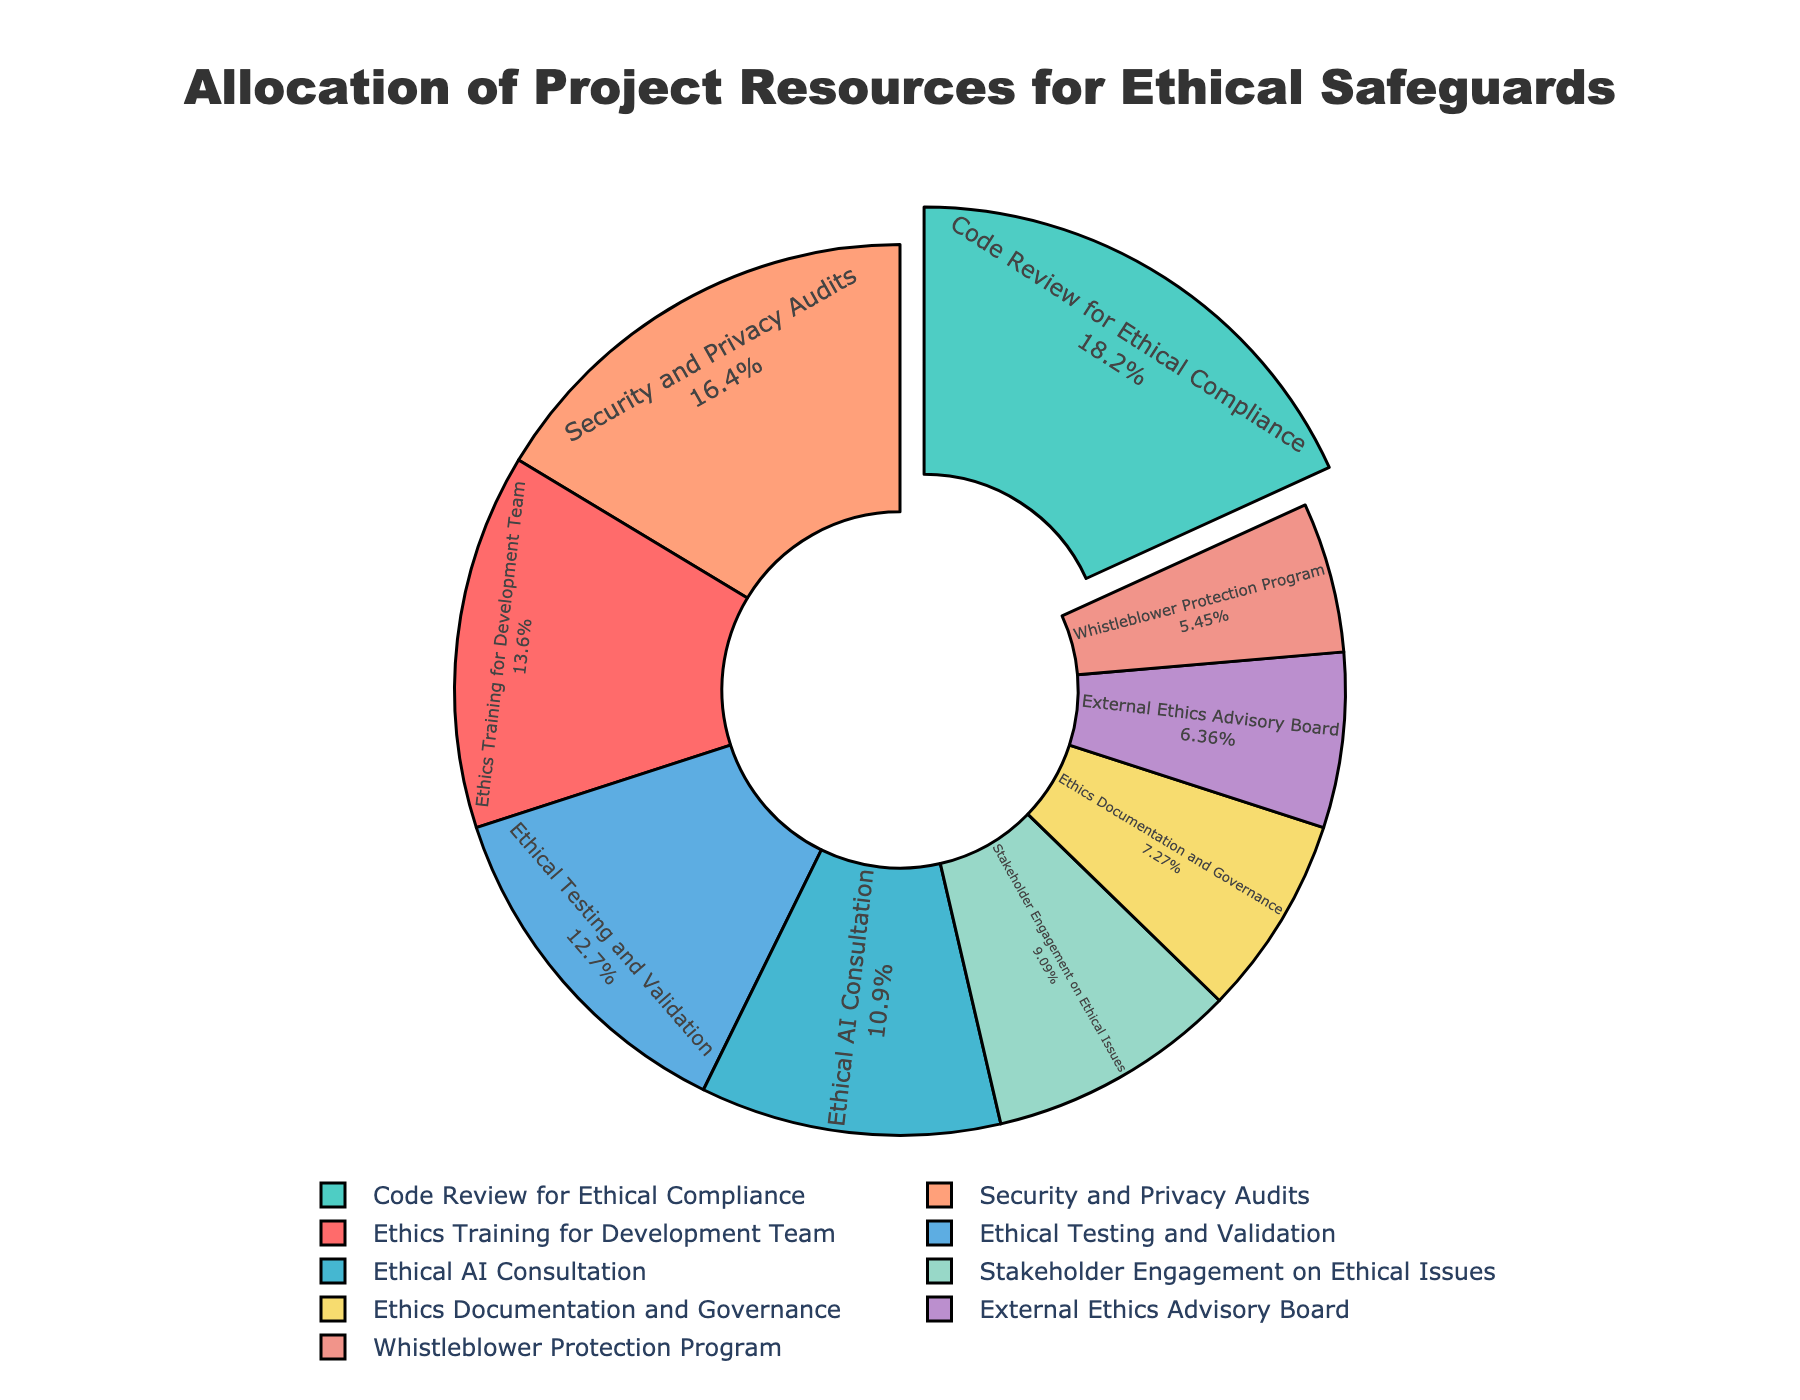What's the largest allocation category? The figure highlights and slightly pulls out the slice with the largest allocation. This visual cue points to "Code Review for Ethical Compliance".
Answer: Code Review for Ethical Compliance What's the combined percentage for Ethics Training for Development Team, Ethical Testing and Validation, and Security and Privacy Audits together? To get the combined percentage, add the percentages of the respective categories: Ethics Training for Development Team (15) + Ethical Testing and Validation (14) + Security and Privacy Audits (18). Calculation: 15 + 14 + 18 = 47.
Answer: 47 Which category has the lowest allocation percentage? By looking at the slices, the smallest slice corresponds to the "Whistleblower Protection Program" category, which has the lowest allocation.
Answer: Whistleblower Protection Program Are there more resources allocated to External Ethics Advisory Board or Stakeholder Engagement on Ethical Issues? Compare the percentages of External Ethics Advisory Board (7) and Stakeholder Engagement on Ethical Issues (10). Since 10% is greater than 7%, Stakeholder Engagement on Ethical Issues has more resources allocated.
Answer: Stakeholder Engagement on Ethical Issues What is the color of the slice representing "Ethics Training for Development Team"? The plot uses specific colors for each category, and the slice labeled "Ethics Training for Development Team" is colored red.
Answer: Red How much more percentage is allocated to Security and Privacy Audits compared to Ethics Documentation and Governance? Subtract the percentage of Ethics Documentation and Governance (8) from Security and Privacy Audits (18). Calculation: 18 - 8 = 10.
Answer: 10 What two categories have the closest allocation percentages? By examining the percentages, Ethical AI Consultation (12) and Ethical Testing and Validation (14) have close allocations with a difference of only 2%.
Answer: Ethical AI Consultation and Ethical Testing and Validation What is the average allocation percentage for all the categories? Sum all the percentages and divide by the number of categories, (15 + 20 + 12 + 18 + 10 + 8 + 7 + 14 + 6) / 9 = 110 / 9 ≈ 12.22.
Answer: ~12.22 Which slice is colored blue, and what percentage does it represent? The plot assigns blue to "Security and Privacy Audits", which is represented by an 18% slice.
Answer: Security and Privacy Audits, 18% How many categories have more than 10% allocation? Identify the categories with percentages over 10: Ethics Training for Development Team (15), Code Review for Ethical Compliance (20), Ethical AI Consultation (12), Security and Privacy Audits (18), Ethical Testing and Validation (14). Count these categories: 5.
Answer: 5 